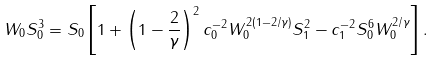<formula> <loc_0><loc_0><loc_500><loc_500>W _ { 0 } S _ { 0 } ^ { 3 } = S _ { 0 } \left [ 1 + \left ( 1 - \frac { 2 } { \gamma } \right ) ^ { 2 } c _ { 0 } ^ { - 2 } W _ { 0 } ^ { 2 ( 1 - 2 / \gamma ) } S _ { 1 } ^ { 2 } - c _ { 1 } ^ { - 2 } S _ { 0 } ^ { 6 } W _ { 0 } ^ { 2 / \gamma } \right ] .</formula> 